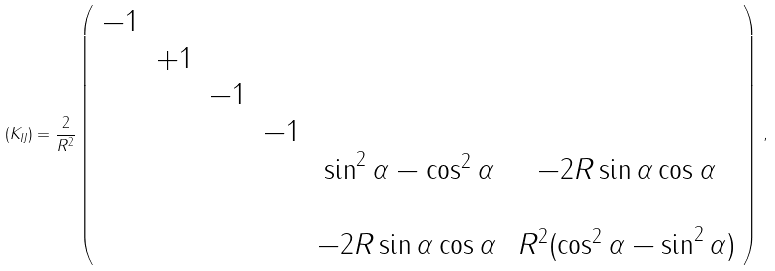<formula> <loc_0><loc_0><loc_500><loc_500>( K _ { I J } ) = \frac { 2 } { R ^ { 2 } } \left ( \begin{array} { c c c c c c } - 1 & & & & & \\ & + 1 & & & & \\ & & - 1 & & & \\ & & & - 1 & & \\ & & & & \sin ^ { 2 } { \alpha } - \cos ^ { 2 } { \alpha } & - 2 R \sin { \alpha } \cos { \alpha } \\ & & & & & \\ & & & & - 2 R \sin { \alpha } \cos { \alpha } \, & R ^ { 2 } ( \cos ^ { 2 } { \alpha } - \sin ^ { 2 } { \alpha } ) \\ \end{array} \right ) \, ,</formula> 